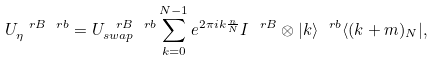<formula> <loc_0><loc_0><loc_500><loc_500>U _ { \eta } ^ { \ r B \ r b } = U ^ { \ r B \ r b } _ { s w a p } \sum _ { k = 0 } ^ { N - 1 } e ^ { 2 \pi i k \frac { n } { N } } I ^ { \ r B } \otimes | k \rangle ^ { \ r b } \langle ( k + m ) _ { N } | ,</formula> 